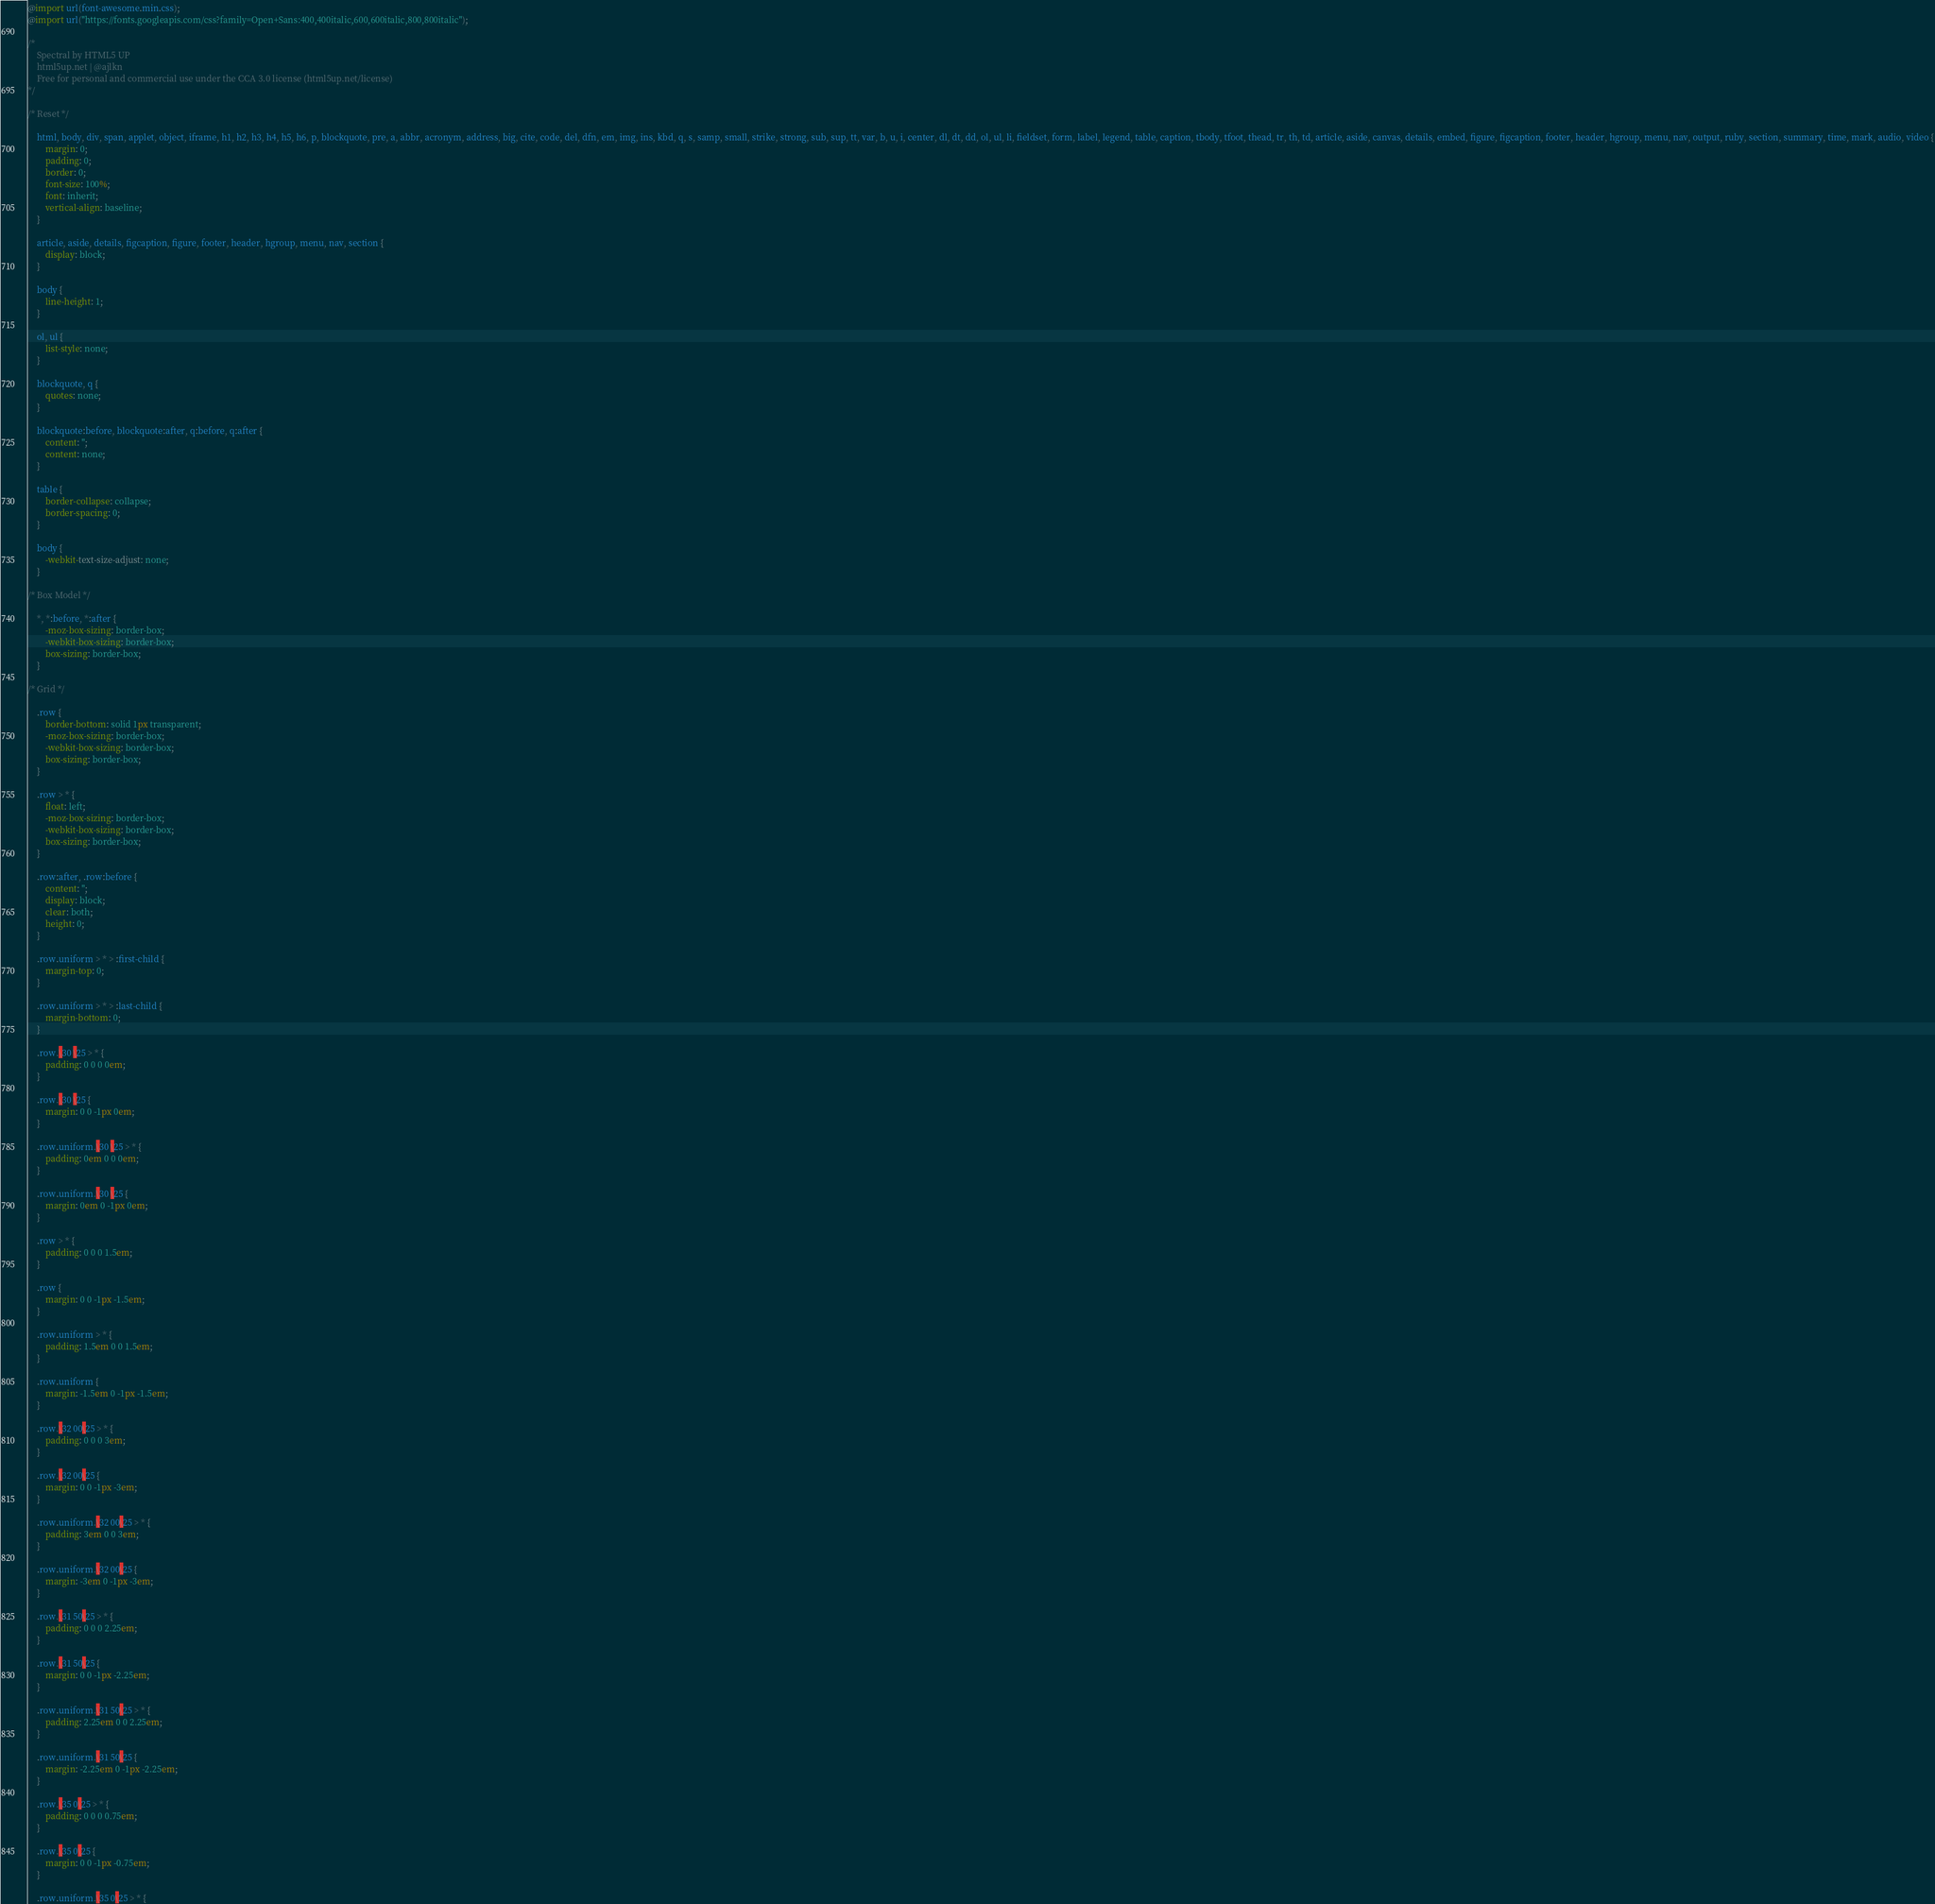Convert code to text. <code><loc_0><loc_0><loc_500><loc_500><_CSS_>@import url(font-awesome.min.css);
@import url("https://fonts.googleapis.com/css?family=Open+Sans:400,400italic,600,600italic,800,800italic");

/*
	Spectral by HTML5 UP
	html5up.net | @ajlkn
	Free for personal and commercial use under the CCA 3.0 license (html5up.net/license)
*/

/* Reset */

	html, body, div, span, applet, object, iframe, h1, h2, h3, h4, h5, h6, p, blockquote, pre, a, abbr, acronym, address, big, cite, code, del, dfn, em, img, ins, kbd, q, s, samp, small, strike, strong, sub, sup, tt, var, b, u, i, center, dl, dt, dd, ol, ul, li, fieldset, form, label, legend, table, caption, tbody, tfoot, thead, tr, th, td, article, aside, canvas, details, embed, figure, figcaption, footer, header, hgroup, menu, nav, output, ruby, section, summary, time, mark, audio, video {
		margin: 0;
		padding: 0;
		border: 0;
		font-size: 100%;
		font: inherit;
		vertical-align: baseline;
	}

	article, aside, details, figcaption, figure, footer, header, hgroup, menu, nav, section {
		display: block;
	}

	body {
		line-height: 1;
	}

	ol, ul {
		list-style: none;
	}

	blockquote, q {
		quotes: none;
	}

	blockquote:before, blockquote:after, q:before, q:after {
		content: '';
		content: none;
	}

	table {
		border-collapse: collapse;
		border-spacing: 0;
	}

	body {
		-webkit-text-size-adjust: none;
	}

/* Box Model */

	*, *:before, *:after {
		-moz-box-sizing: border-box;
		-webkit-box-sizing: border-box;
		box-sizing: border-box;
	}

/* Grid */

	.row {
		border-bottom: solid 1px transparent;
		-moz-box-sizing: border-box;
		-webkit-box-sizing: border-box;
		box-sizing: border-box;
	}

	.row > * {
		float: left;
		-moz-box-sizing: border-box;
		-webkit-box-sizing: border-box;
		box-sizing: border-box;
	}

	.row:after, .row:before {
		content: '';
		display: block;
		clear: both;
		height: 0;
	}

	.row.uniform > * > :first-child {
		margin-top: 0;
	}

	.row.uniform > * > :last-child {
		margin-bottom: 0;
	}

	.row.\30 \25 > * {
		padding: 0 0 0 0em;
	}

	.row.\30 \25 {
		margin: 0 0 -1px 0em;
	}

	.row.uniform.\30 \25 > * {
		padding: 0em 0 0 0em;
	}

	.row.uniform.\30 \25 {
		margin: 0em 0 -1px 0em;
	}

	.row > * {
		padding: 0 0 0 1.5em;
	}

	.row {
		margin: 0 0 -1px -1.5em;
	}

	.row.uniform > * {
		padding: 1.5em 0 0 1.5em;
	}

	.row.uniform {
		margin: -1.5em 0 -1px -1.5em;
	}

	.row.\32 00\25 > * {
		padding: 0 0 0 3em;
	}

	.row.\32 00\25 {
		margin: 0 0 -1px -3em;
	}

	.row.uniform.\32 00\25 > * {
		padding: 3em 0 0 3em;
	}

	.row.uniform.\32 00\25 {
		margin: -3em 0 -1px -3em;
	}

	.row.\31 50\25 > * {
		padding: 0 0 0 2.25em;
	}

	.row.\31 50\25 {
		margin: 0 0 -1px -2.25em;
	}

	.row.uniform.\31 50\25 > * {
		padding: 2.25em 0 0 2.25em;
	}

	.row.uniform.\31 50\25 {
		margin: -2.25em 0 -1px -2.25em;
	}

	.row.\35 0\25 > * {
		padding: 0 0 0 0.75em;
	}

	.row.\35 0\25 {
		margin: 0 0 -1px -0.75em;
	}

	.row.uniform.\35 0\25 > * {</code> 